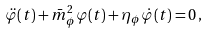<formula> <loc_0><loc_0><loc_500><loc_500>\ddot { \varphi } ( t ) + \bar { m } _ { \phi } ^ { 2 } \varphi ( t ) + \eta _ { \phi } \dot { \varphi } ( t ) = 0 \, ,</formula> 